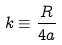<formula> <loc_0><loc_0><loc_500><loc_500>k \equiv \frac { R } { 4 a }</formula> 